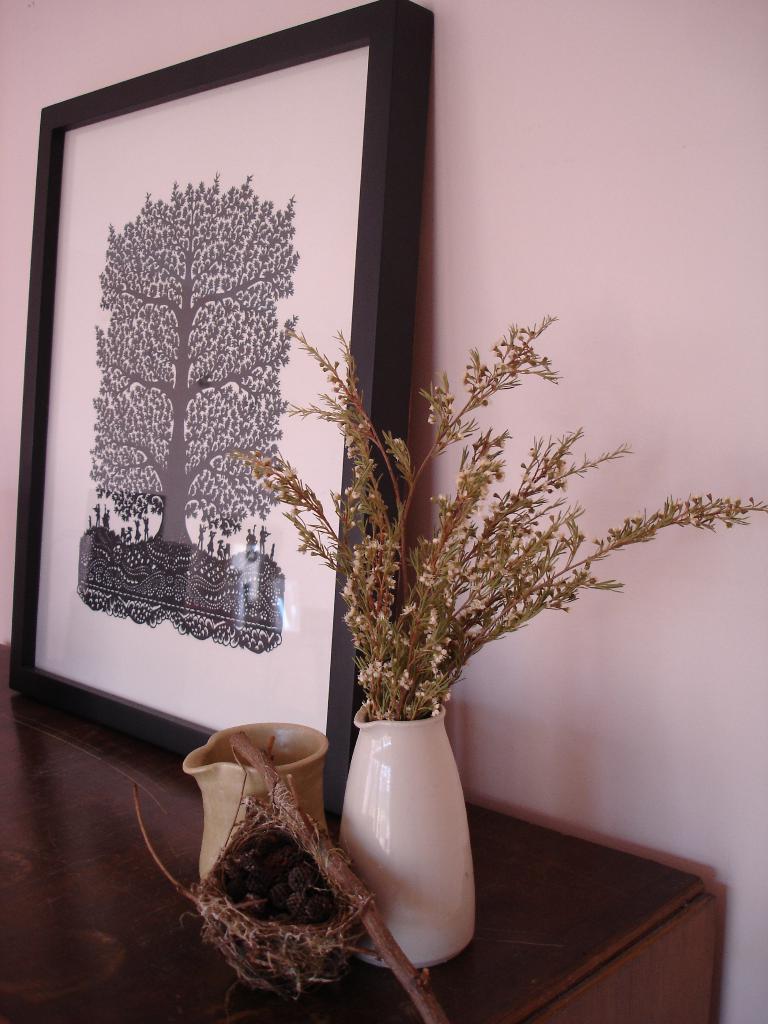Please provide a concise description of this image. In this image, I can see a photo frame, flower vase, jar and it looks like a nest, which are on the table. In the background, there is a wall. 